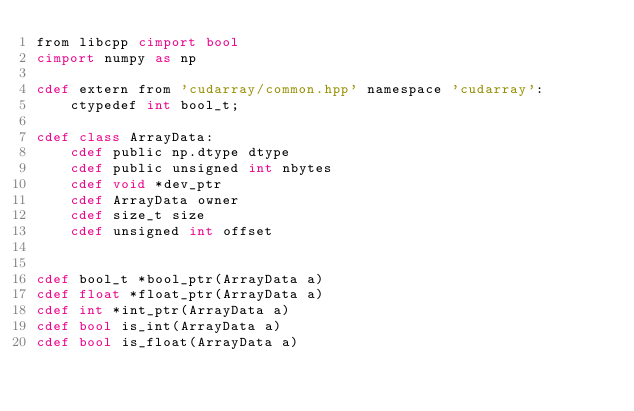Convert code to text. <code><loc_0><loc_0><loc_500><loc_500><_Cython_>from libcpp cimport bool
cimport numpy as np

cdef extern from 'cudarray/common.hpp' namespace 'cudarray':
    ctypedef int bool_t;

cdef class ArrayData:
    cdef public np.dtype dtype
    cdef public unsigned int nbytes
    cdef void *dev_ptr
    cdef ArrayData owner
    cdef size_t size
    cdef unsigned int offset


cdef bool_t *bool_ptr(ArrayData a)
cdef float *float_ptr(ArrayData a)
cdef int *int_ptr(ArrayData a)
cdef bool is_int(ArrayData a)
cdef bool is_float(ArrayData a)
</code> 